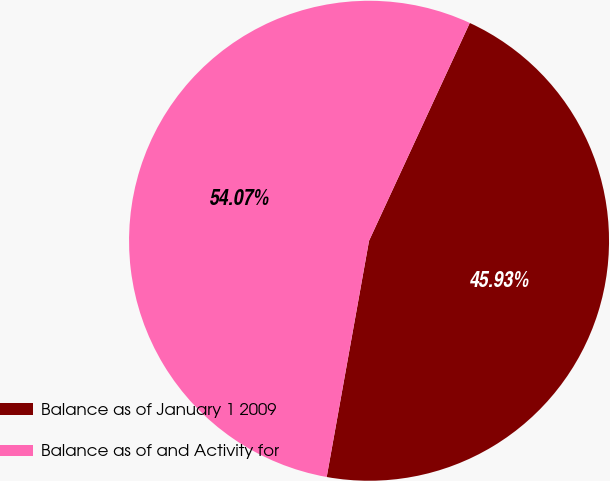<chart> <loc_0><loc_0><loc_500><loc_500><pie_chart><fcel>Balance as of January 1 2009<fcel>Balance as of and Activity for<nl><fcel>45.93%<fcel>54.07%<nl></chart> 